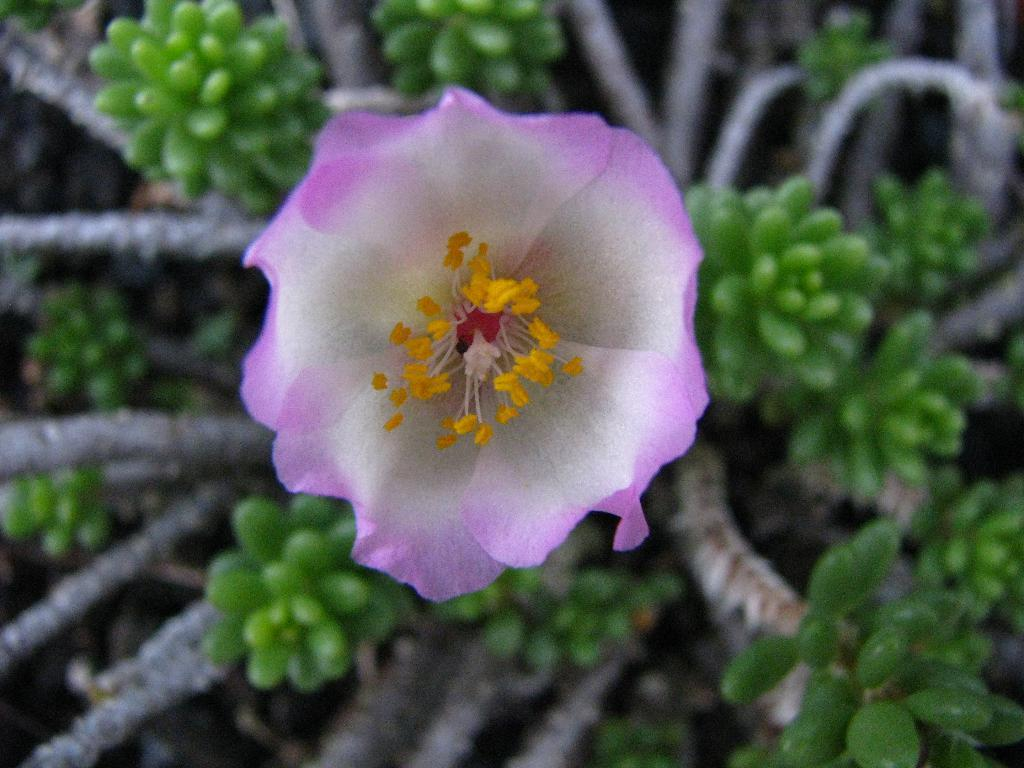What type of plant can be seen in the image? There is a flower and buds in the image, which are part of a plant. Can you describe the stage of growth for the plant in the image? The plant in the image has both buds and a flower, indicating that it is in a stage of growth where it is producing flowers. What parts of the plant are visible in the image? The image shows branches of the plant, as well as the buds and flower. What type of wall is visible behind the plant in the image? There is no wall visible in the image; it only shows the plant with its branches, buds, and flower. 